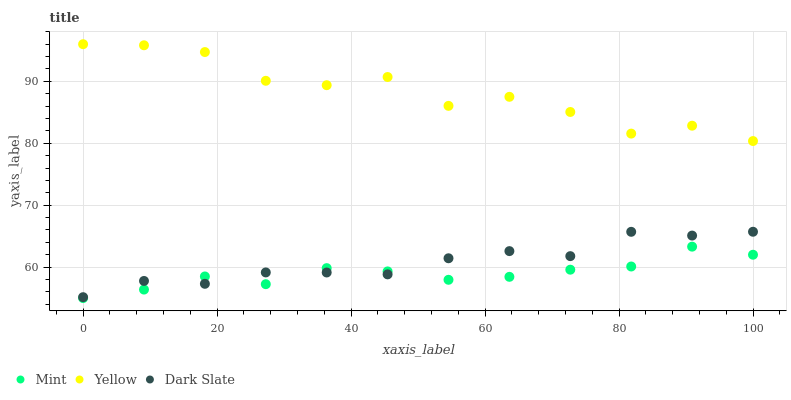Does Mint have the minimum area under the curve?
Answer yes or no. Yes. Does Yellow have the maximum area under the curve?
Answer yes or no. Yes. Does Yellow have the minimum area under the curve?
Answer yes or no. No. Does Mint have the maximum area under the curve?
Answer yes or no. No. Is Mint the smoothest?
Answer yes or no. Yes. Is Yellow the roughest?
Answer yes or no. Yes. Is Yellow the smoothest?
Answer yes or no. No. Is Mint the roughest?
Answer yes or no. No. Does Mint have the lowest value?
Answer yes or no. Yes. Does Yellow have the lowest value?
Answer yes or no. No. Does Yellow have the highest value?
Answer yes or no. Yes. Does Mint have the highest value?
Answer yes or no. No. Is Dark Slate less than Yellow?
Answer yes or no. Yes. Is Yellow greater than Mint?
Answer yes or no. Yes. Does Dark Slate intersect Mint?
Answer yes or no. Yes. Is Dark Slate less than Mint?
Answer yes or no. No. Is Dark Slate greater than Mint?
Answer yes or no. No. Does Dark Slate intersect Yellow?
Answer yes or no. No. 